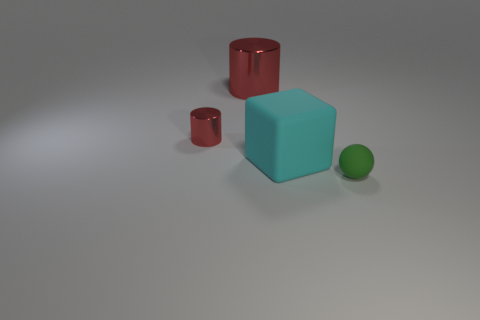Subtract all cubes. How many objects are left? 3 Add 2 yellow cylinders. How many yellow cylinders exist? 2 Add 2 cyan matte objects. How many objects exist? 6 Subtract 1 red cylinders. How many objects are left? 3 Subtract 2 cylinders. How many cylinders are left? 0 Subtract all gray cylinders. Subtract all yellow balls. How many cylinders are left? 2 Subtract all red shiny cylinders. Subtract all red cylinders. How many objects are left? 0 Add 1 red things. How many red things are left? 3 